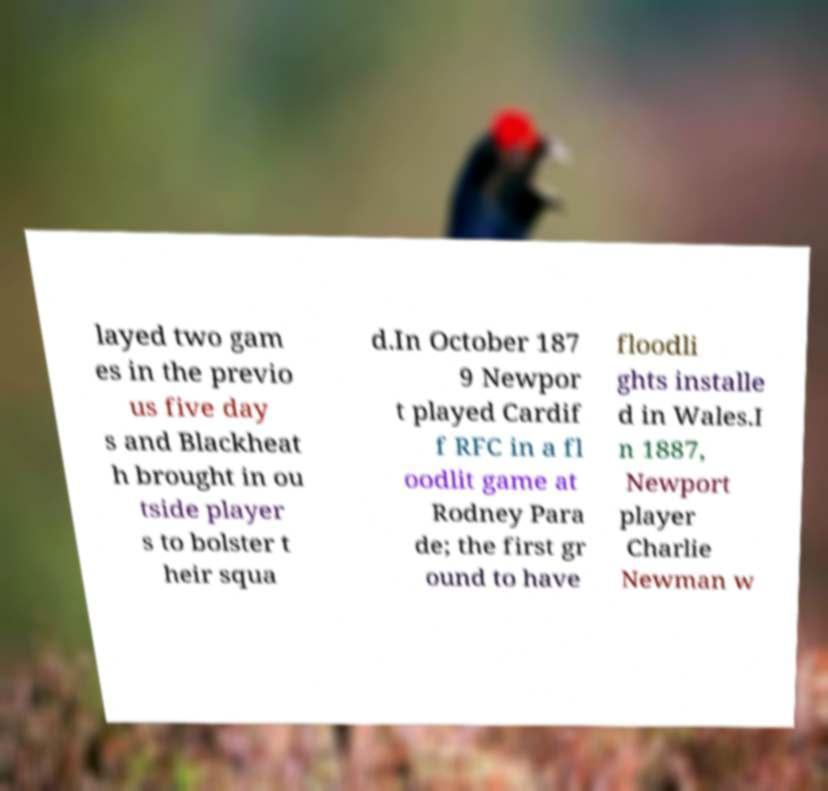There's text embedded in this image that I need extracted. Can you transcribe it verbatim? layed two gam es in the previo us five day s and Blackheat h brought in ou tside player s to bolster t heir squa d.In October 187 9 Newpor t played Cardif f RFC in a fl oodlit game at Rodney Para de; the first gr ound to have floodli ghts installe d in Wales.I n 1887, Newport player Charlie Newman w 